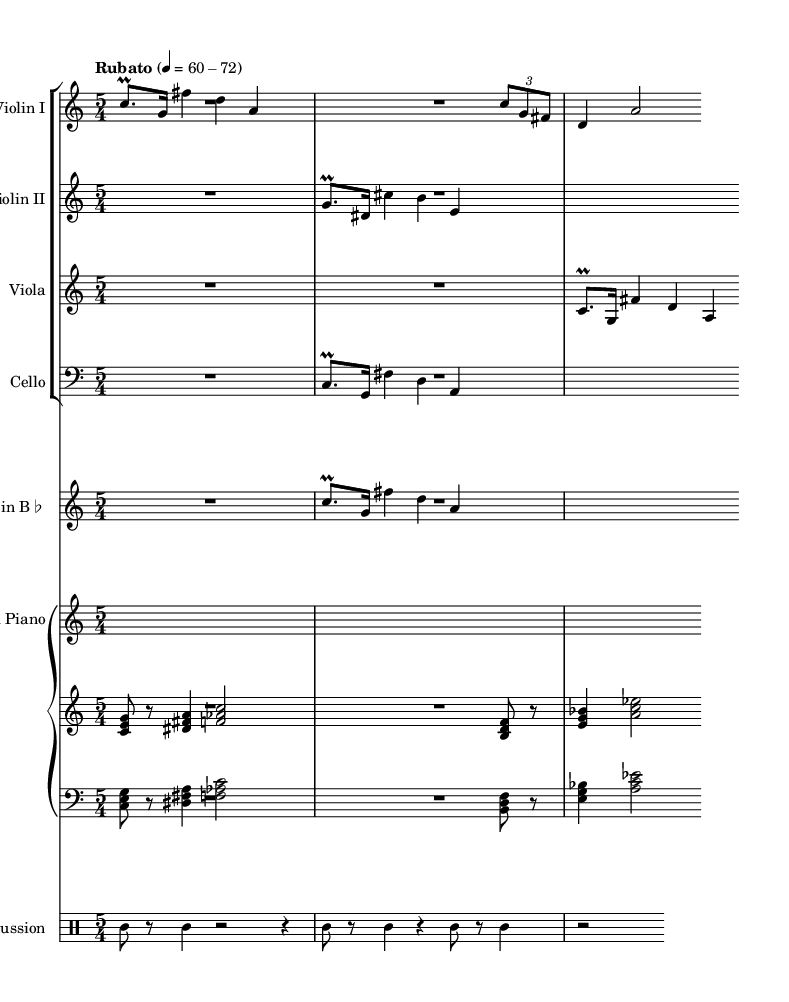What is the time signature of this music? The time signature is indicated at the beginning of the score, which shows 5 over 4. This means there are five beats in a measure, with each beat being a quarter note.
Answer: 5/4 What is the tempo marking of the piece? The tempo marking is found in the top left corner of the score, stating "Rubato" with a specific metronome range of 60-72 beats per minute. This indicates a flexible tempo that allows for expressive tempo variations.
Answer: Rubato, 60-72 What instruments are featured in this score? The score lists several instruments, which can all be found in the header of each staff. They include Violin I, Violin II, Viola, Cello, Clarinet in B♭, Prepared Piano, and Percussion.
Answer: Violin I, Violin II, Viola, Cello, Clarinet in B♭, Prepared Piano, Percussion How many measures are in the first violin part? To determine the number of measures, we look at the end of the Violin I staff. Counting the bars in the rendered section indicates four measures in that part.
Answer: 4 What technique is used for the violin parts? The score indicates the use of a specific performance technique with the notation of prall, which refers to a rapid alternation between two notes. This suggests a particular expressive style often used in avant-garde compositions.
Answer: Prall How does the piano part differ from the string instruments in terms of structure? The piano part is written on two staves (treble and bass), featuring chordal and melodic structures that differ from the string instruments, which have single melodic lines. The prepared piano adds an experimental texture by contrasting with linear string lines.
Answer: Two staves 